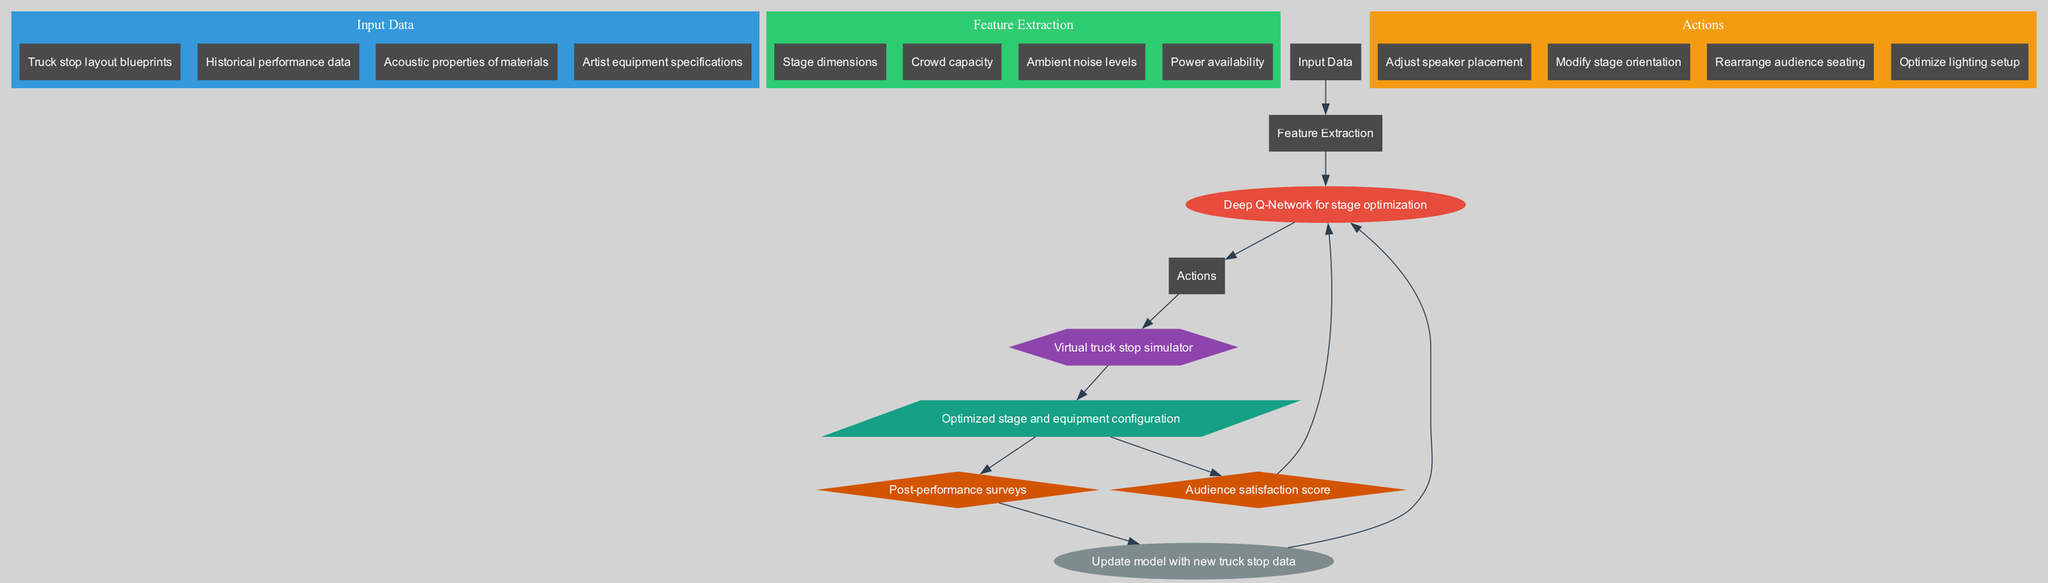What's the model used in this diagram? The diagram specifies that the model used is a "Deep Q-Network for stage optimization," which can be found in the model node.
Answer: Deep Q-Network for stage optimization How many actions are described in the diagram? There are four actions listed in the Actions cluster: "Adjust speaker placement," "Modify stage orientation," "Rearrange audience seating," and "Optimize lighting setup." Therefore, the count of actions is determined by the items in that cluster.
Answer: 4 What is the reward function in this system? The diagram indicates that the reward function is "Audience satisfaction score," which is shown in the reward node.
Answer: Audience satisfaction score Which element is used to represent the environment in this diagram? The environment is illustrated by a hexagon-shaped node labeled "Virtual truck stop simulator." The shape and label both point to its identity within the diagram.
Answer: Virtual truck stop simulator What does the feedback loop connect to in the diagram? The feedback loop node, labeled "Post-performance surveys," connects to the learning node labeled "Update model with new truck stop data," indicating that survey feedback is used for model updating.
Answer: Update model with new truck stop data What type of data is fed into the feature extraction process? The input data section indicates that the data includes "Truck stop layout blueprints," "Historical performance data," "Acoustic properties of materials," and "Artist equipment specifications," which are inputs that feed into feature extraction.
Answer: Truck stop layout blueprints, Historical performance data, Acoustic properties of materials, Artist equipment specifications What is the output of this reinforcement learning system? The output node indicates that the system produces an "Optimized stage and equipment configuration," summarizing the end result after processing through the diagram.
Answer: Optimized stage and equipment configuration Which shape represents the actions in the diagram? The actions are represented by rectangle-shaped nodes in the Actions cluster, denoting the nature of the actions involved in the reinforcement learning process.
Answer: Rectangle-shaped nodes How does the reinforcement learning model update itself? The model's update mechanism is linked through the feedback loop, which incorporates responses from the "Post-performance surveys" that help in updating the model with new truck stop data.
Answer: Update model with new truck stop data 